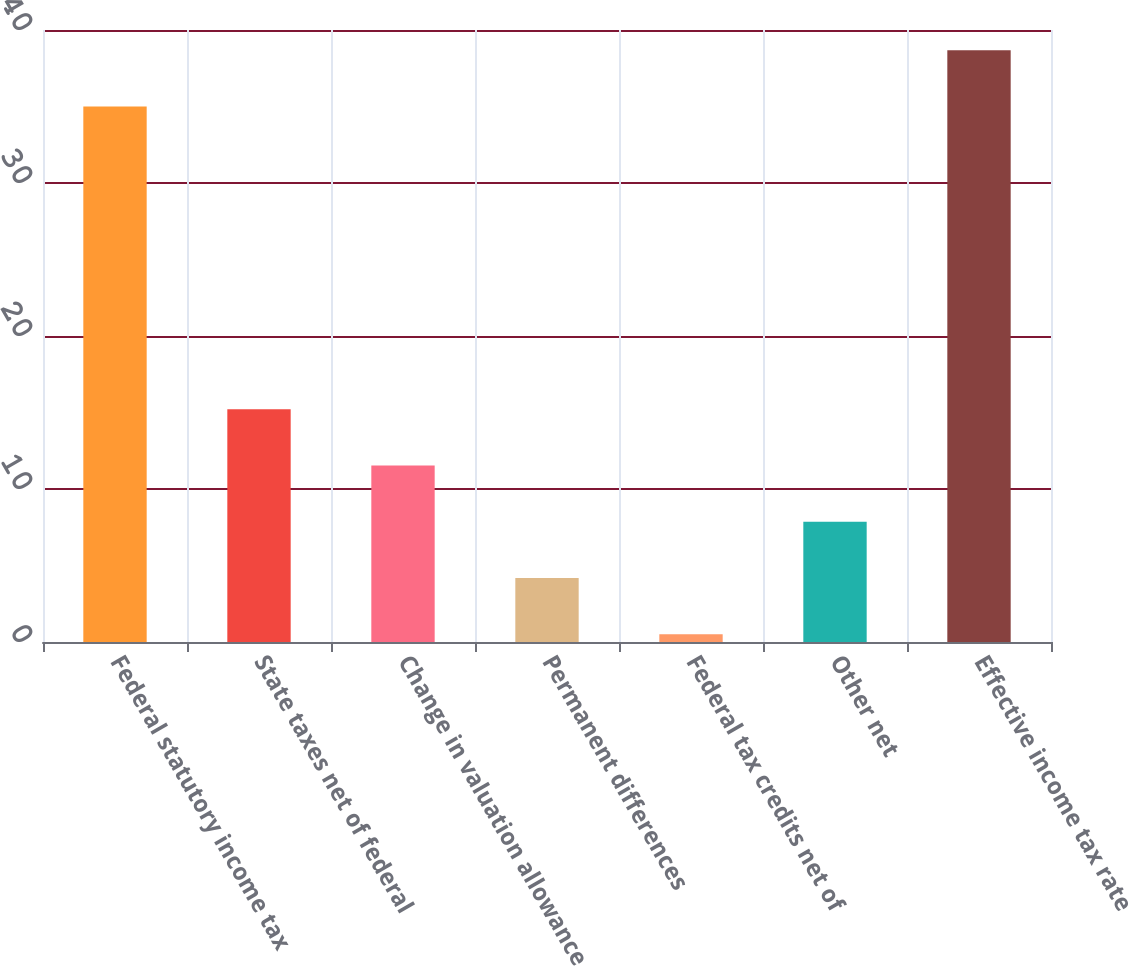<chart> <loc_0><loc_0><loc_500><loc_500><bar_chart><fcel>Federal statutory income tax<fcel>State taxes net of federal<fcel>Change in valuation allowance<fcel>Permanent differences<fcel>Federal tax credits net of<fcel>Other net<fcel>Effective income tax rate<nl><fcel>35<fcel>15.22<fcel>11.54<fcel>4.18<fcel>0.5<fcel>7.86<fcel>38.68<nl></chart> 